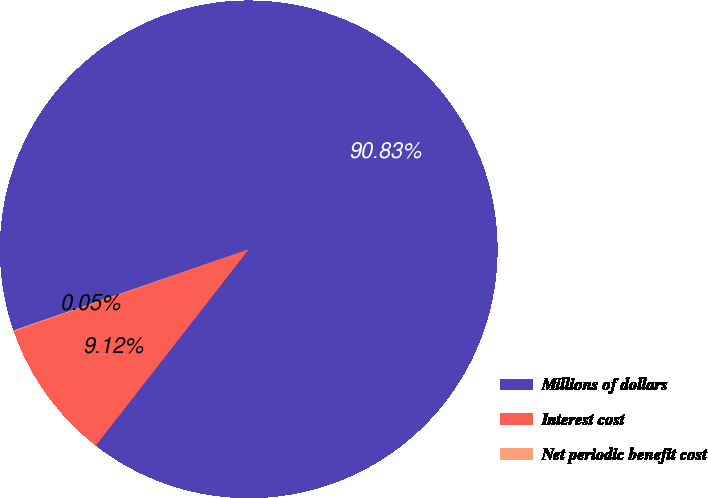Convert chart to OTSL. <chart><loc_0><loc_0><loc_500><loc_500><pie_chart><fcel>Millions of dollars<fcel>Interest cost<fcel>Net periodic benefit cost<nl><fcel>90.83%<fcel>9.12%<fcel>0.05%<nl></chart> 